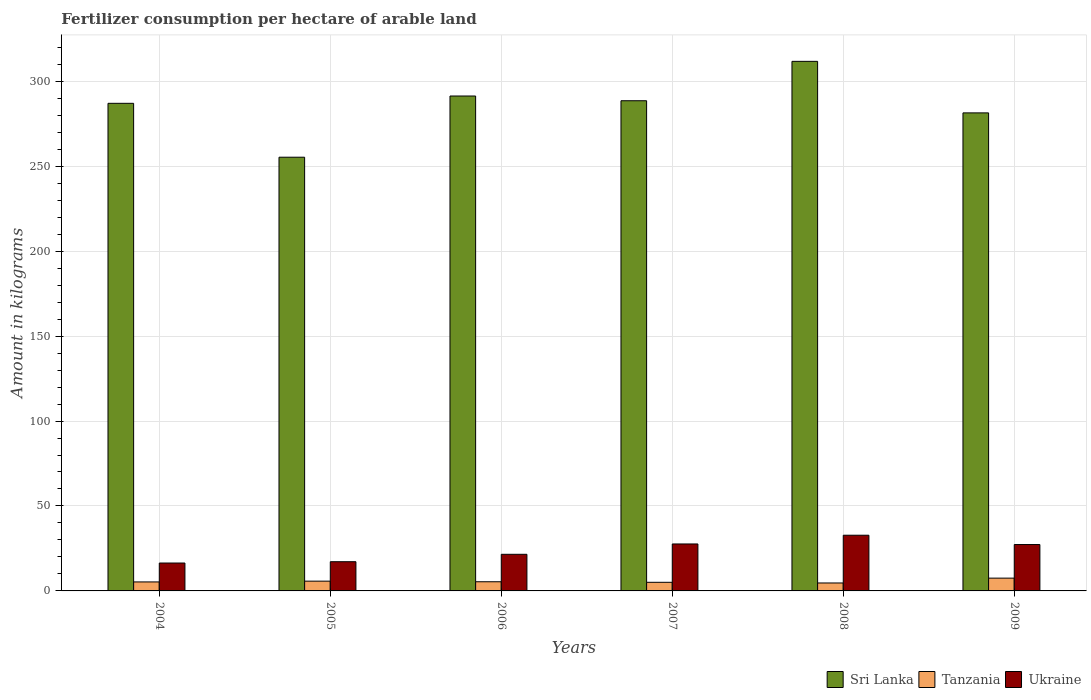Are the number of bars per tick equal to the number of legend labels?
Ensure brevity in your answer.  Yes. Are the number of bars on each tick of the X-axis equal?
Your answer should be compact. Yes. How many bars are there on the 3rd tick from the right?
Provide a short and direct response. 3. What is the label of the 4th group of bars from the left?
Offer a terse response. 2007. In how many cases, is the number of bars for a given year not equal to the number of legend labels?
Offer a terse response. 0. What is the amount of fertilizer consumption in Tanzania in 2006?
Your response must be concise. 5.4. Across all years, what is the maximum amount of fertilizer consumption in Ukraine?
Provide a short and direct response. 32.79. Across all years, what is the minimum amount of fertilizer consumption in Tanzania?
Ensure brevity in your answer.  4.68. In which year was the amount of fertilizer consumption in Sri Lanka minimum?
Your answer should be compact. 2005. What is the total amount of fertilizer consumption in Ukraine in the graph?
Provide a short and direct response. 142.89. What is the difference between the amount of fertilizer consumption in Tanzania in 2004 and that in 2008?
Ensure brevity in your answer.  0.61. What is the difference between the amount of fertilizer consumption in Ukraine in 2005 and the amount of fertilizer consumption in Sri Lanka in 2009?
Your response must be concise. -264.18. What is the average amount of fertilizer consumption in Sri Lanka per year?
Make the answer very short. 285.87. In the year 2004, what is the difference between the amount of fertilizer consumption in Ukraine and amount of fertilizer consumption in Tanzania?
Provide a short and direct response. 11.13. What is the ratio of the amount of fertilizer consumption in Tanzania in 2004 to that in 2006?
Your answer should be very brief. 0.98. What is the difference between the highest and the second highest amount of fertilizer consumption in Ukraine?
Keep it short and to the point. 5.15. What is the difference between the highest and the lowest amount of fertilizer consumption in Ukraine?
Keep it short and to the point. 16.37. Is the sum of the amount of fertilizer consumption in Tanzania in 2004 and 2006 greater than the maximum amount of fertilizer consumption in Ukraine across all years?
Your response must be concise. No. What does the 1st bar from the left in 2005 represents?
Provide a succinct answer. Sri Lanka. What does the 2nd bar from the right in 2004 represents?
Your answer should be compact. Tanzania. Are all the bars in the graph horizontal?
Your answer should be compact. No. Are the values on the major ticks of Y-axis written in scientific E-notation?
Keep it short and to the point. No. Does the graph contain grids?
Give a very brief answer. Yes. Where does the legend appear in the graph?
Your answer should be very brief. Bottom right. How are the legend labels stacked?
Your response must be concise. Horizontal. What is the title of the graph?
Provide a succinct answer. Fertilizer consumption per hectare of arable land. What is the label or title of the Y-axis?
Make the answer very short. Amount in kilograms. What is the Amount in kilograms of Sri Lanka in 2004?
Your answer should be compact. 287.01. What is the Amount in kilograms in Tanzania in 2004?
Provide a succinct answer. 5.29. What is the Amount in kilograms of Ukraine in 2004?
Make the answer very short. 16.42. What is the Amount in kilograms in Sri Lanka in 2005?
Give a very brief answer. 255.29. What is the Amount in kilograms in Tanzania in 2005?
Offer a terse response. 5.75. What is the Amount in kilograms in Ukraine in 2005?
Your response must be concise. 17.19. What is the Amount in kilograms of Sri Lanka in 2006?
Keep it short and to the point. 291.32. What is the Amount in kilograms of Tanzania in 2006?
Offer a terse response. 5.4. What is the Amount in kilograms of Ukraine in 2006?
Make the answer very short. 21.55. What is the Amount in kilograms in Sri Lanka in 2007?
Keep it short and to the point. 288.52. What is the Amount in kilograms in Tanzania in 2007?
Give a very brief answer. 5.07. What is the Amount in kilograms of Ukraine in 2007?
Offer a very short reply. 27.64. What is the Amount in kilograms in Sri Lanka in 2008?
Provide a short and direct response. 311.71. What is the Amount in kilograms in Tanzania in 2008?
Provide a succinct answer. 4.68. What is the Amount in kilograms of Ukraine in 2008?
Provide a succinct answer. 32.79. What is the Amount in kilograms of Sri Lanka in 2009?
Give a very brief answer. 281.38. What is the Amount in kilograms of Tanzania in 2009?
Provide a succinct answer. 7.52. What is the Amount in kilograms in Ukraine in 2009?
Provide a succinct answer. 27.3. Across all years, what is the maximum Amount in kilograms in Sri Lanka?
Give a very brief answer. 311.71. Across all years, what is the maximum Amount in kilograms of Tanzania?
Offer a very short reply. 7.52. Across all years, what is the maximum Amount in kilograms in Ukraine?
Give a very brief answer. 32.79. Across all years, what is the minimum Amount in kilograms in Sri Lanka?
Provide a succinct answer. 255.29. Across all years, what is the minimum Amount in kilograms in Tanzania?
Provide a succinct answer. 4.68. Across all years, what is the minimum Amount in kilograms of Ukraine?
Your answer should be very brief. 16.42. What is the total Amount in kilograms of Sri Lanka in the graph?
Make the answer very short. 1715.23. What is the total Amount in kilograms in Tanzania in the graph?
Offer a terse response. 33.71. What is the total Amount in kilograms of Ukraine in the graph?
Give a very brief answer. 142.89. What is the difference between the Amount in kilograms in Sri Lanka in 2004 and that in 2005?
Keep it short and to the point. 31.72. What is the difference between the Amount in kilograms in Tanzania in 2004 and that in 2005?
Keep it short and to the point. -0.47. What is the difference between the Amount in kilograms of Ukraine in 2004 and that in 2005?
Your answer should be very brief. -0.77. What is the difference between the Amount in kilograms of Sri Lanka in 2004 and that in 2006?
Your answer should be very brief. -4.31. What is the difference between the Amount in kilograms of Tanzania in 2004 and that in 2006?
Keep it short and to the point. -0.11. What is the difference between the Amount in kilograms of Ukraine in 2004 and that in 2006?
Your answer should be very brief. -5.14. What is the difference between the Amount in kilograms of Sri Lanka in 2004 and that in 2007?
Your answer should be compact. -1.51. What is the difference between the Amount in kilograms of Tanzania in 2004 and that in 2007?
Offer a very short reply. 0.22. What is the difference between the Amount in kilograms in Ukraine in 2004 and that in 2007?
Your answer should be compact. -11.22. What is the difference between the Amount in kilograms of Sri Lanka in 2004 and that in 2008?
Your answer should be very brief. -24.7. What is the difference between the Amount in kilograms of Tanzania in 2004 and that in 2008?
Offer a terse response. 0.61. What is the difference between the Amount in kilograms of Ukraine in 2004 and that in 2008?
Make the answer very short. -16.37. What is the difference between the Amount in kilograms of Sri Lanka in 2004 and that in 2009?
Your response must be concise. 5.63. What is the difference between the Amount in kilograms in Tanzania in 2004 and that in 2009?
Offer a very short reply. -2.24. What is the difference between the Amount in kilograms of Ukraine in 2004 and that in 2009?
Your answer should be compact. -10.89. What is the difference between the Amount in kilograms in Sri Lanka in 2005 and that in 2006?
Offer a very short reply. -36.02. What is the difference between the Amount in kilograms of Tanzania in 2005 and that in 2006?
Provide a succinct answer. 0.36. What is the difference between the Amount in kilograms of Ukraine in 2005 and that in 2006?
Ensure brevity in your answer.  -4.36. What is the difference between the Amount in kilograms of Sri Lanka in 2005 and that in 2007?
Keep it short and to the point. -33.23. What is the difference between the Amount in kilograms of Tanzania in 2005 and that in 2007?
Provide a succinct answer. 0.68. What is the difference between the Amount in kilograms of Ukraine in 2005 and that in 2007?
Your answer should be compact. -10.45. What is the difference between the Amount in kilograms in Sri Lanka in 2005 and that in 2008?
Ensure brevity in your answer.  -56.42. What is the difference between the Amount in kilograms in Tanzania in 2005 and that in 2008?
Offer a terse response. 1.08. What is the difference between the Amount in kilograms of Ukraine in 2005 and that in 2008?
Keep it short and to the point. -15.59. What is the difference between the Amount in kilograms in Sri Lanka in 2005 and that in 2009?
Make the answer very short. -26.08. What is the difference between the Amount in kilograms of Tanzania in 2005 and that in 2009?
Keep it short and to the point. -1.77. What is the difference between the Amount in kilograms in Ukraine in 2005 and that in 2009?
Offer a very short reply. -10.11. What is the difference between the Amount in kilograms in Sri Lanka in 2006 and that in 2007?
Offer a very short reply. 2.79. What is the difference between the Amount in kilograms in Tanzania in 2006 and that in 2007?
Offer a terse response. 0.33. What is the difference between the Amount in kilograms of Ukraine in 2006 and that in 2007?
Your answer should be compact. -6.09. What is the difference between the Amount in kilograms of Sri Lanka in 2006 and that in 2008?
Your response must be concise. -20.4. What is the difference between the Amount in kilograms of Tanzania in 2006 and that in 2008?
Provide a short and direct response. 0.72. What is the difference between the Amount in kilograms in Ukraine in 2006 and that in 2008?
Offer a very short reply. -11.23. What is the difference between the Amount in kilograms of Sri Lanka in 2006 and that in 2009?
Your answer should be very brief. 9.94. What is the difference between the Amount in kilograms in Tanzania in 2006 and that in 2009?
Ensure brevity in your answer.  -2.13. What is the difference between the Amount in kilograms in Ukraine in 2006 and that in 2009?
Give a very brief answer. -5.75. What is the difference between the Amount in kilograms in Sri Lanka in 2007 and that in 2008?
Make the answer very short. -23.19. What is the difference between the Amount in kilograms of Tanzania in 2007 and that in 2008?
Offer a terse response. 0.4. What is the difference between the Amount in kilograms of Ukraine in 2007 and that in 2008?
Your response must be concise. -5.15. What is the difference between the Amount in kilograms of Sri Lanka in 2007 and that in 2009?
Keep it short and to the point. 7.15. What is the difference between the Amount in kilograms of Tanzania in 2007 and that in 2009?
Your answer should be very brief. -2.45. What is the difference between the Amount in kilograms of Ukraine in 2007 and that in 2009?
Ensure brevity in your answer.  0.34. What is the difference between the Amount in kilograms in Sri Lanka in 2008 and that in 2009?
Ensure brevity in your answer.  30.34. What is the difference between the Amount in kilograms in Tanzania in 2008 and that in 2009?
Keep it short and to the point. -2.85. What is the difference between the Amount in kilograms in Ukraine in 2008 and that in 2009?
Your response must be concise. 5.48. What is the difference between the Amount in kilograms of Sri Lanka in 2004 and the Amount in kilograms of Tanzania in 2005?
Your answer should be compact. 281.26. What is the difference between the Amount in kilograms of Sri Lanka in 2004 and the Amount in kilograms of Ukraine in 2005?
Keep it short and to the point. 269.82. What is the difference between the Amount in kilograms of Tanzania in 2004 and the Amount in kilograms of Ukraine in 2005?
Provide a short and direct response. -11.9. What is the difference between the Amount in kilograms of Sri Lanka in 2004 and the Amount in kilograms of Tanzania in 2006?
Provide a succinct answer. 281.61. What is the difference between the Amount in kilograms of Sri Lanka in 2004 and the Amount in kilograms of Ukraine in 2006?
Your response must be concise. 265.46. What is the difference between the Amount in kilograms of Tanzania in 2004 and the Amount in kilograms of Ukraine in 2006?
Your answer should be compact. -16.26. What is the difference between the Amount in kilograms of Sri Lanka in 2004 and the Amount in kilograms of Tanzania in 2007?
Ensure brevity in your answer.  281.94. What is the difference between the Amount in kilograms of Sri Lanka in 2004 and the Amount in kilograms of Ukraine in 2007?
Keep it short and to the point. 259.37. What is the difference between the Amount in kilograms in Tanzania in 2004 and the Amount in kilograms in Ukraine in 2007?
Give a very brief answer. -22.35. What is the difference between the Amount in kilograms in Sri Lanka in 2004 and the Amount in kilograms in Tanzania in 2008?
Ensure brevity in your answer.  282.33. What is the difference between the Amount in kilograms of Sri Lanka in 2004 and the Amount in kilograms of Ukraine in 2008?
Give a very brief answer. 254.22. What is the difference between the Amount in kilograms of Tanzania in 2004 and the Amount in kilograms of Ukraine in 2008?
Give a very brief answer. -27.5. What is the difference between the Amount in kilograms in Sri Lanka in 2004 and the Amount in kilograms in Tanzania in 2009?
Provide a short and direct response. 279.49. What is the difference between the Amount in kilograms of Sri Lanka in 2004 and the Amount in kilograms of Ukraine in 2009?
Provide a short and direct response. 259.71. What is the difference between the Amount in kilograms of Tanzania in 2004 and the Amount in kilograms of Ukraine in 2009?
Keep it short and to the point. -22.01. What is the difference between the Amount in kilograms of Sri Lanka in 2005 and the Amount in kilograms of Tanzania in 2006?
Keep it short and to the point. 249.89. What is the difference between the Amount in kilograms of Sri Lanka in 2005 and the Amount in kilograms of Ukraine in 2006?
Ensure brevity in your answer.  233.74. What is the difference between the Amount in kilograms in Tanzania in 2005 and the Amount in kilograms in Ukraine in 2006?
Keep it short and to the point. -15.8. What is the difference between the Amount in kilograms of Sri Lanka in 2005 and the Amount in kilograms of Tanzania in 2007?
Your answer should be very brief. 250.22. What is the difference between the Amount in kilograms in Sri Lanka in 2005 and the Amount in kilograms in Ukraine in 2007?
Offer a very short reply. 227.65. What is the difference between the Amount in kilograms of Tanzania in 2005 and the Amount in kilograms of Ukraine in 2007?
Make the answer very short. -21.88. What is the difference between the Amount in kilograms of Sri Lanka in 2005 and the Amount in kilograms of Tanzania in 2008?
Provide a short and direct response. 250.62. What is the difference between the Amount in kilograms of Sri Lanka in 2005 and the Amount in kilograms of Ukraine in 2008?
Offer a terse response. 222.5. What is the difference between the Amount in kilograms in Tanzania in 2005 and the Amount in kilograms in Ukraine in 2008?
Your answer should be very brief. -27.03. What is the difference between the Amount in kilograms of Sri Lanka in 2005 and the Amount in kilograms of Tanzania in 2009?
Ensure brevity in your answer.  247.77. What is the difference between the Amount in kilograms in Sri Lanka in 2005 and the Amount in kilograms in Ukraine in 2009?
Ensure brevity in your answer.  227.99. What is the difference between the Amount in kilograms of Tanzania in 2005 and the Amount in kilograms of Ukraine in 2009?
Give a very brief answer. -21.55. What is the difference between the Amount in kilograms of Sri Lanka in 2006 and the Amount in kilograms of Tanzania in 2007?
Provide a short and direct response. 286.24. What is the difference between the Amount in kilograms in Sri Lanka in 2006 and the Amount in kilograms in Ukraine in 2007?
Ensure brevity in your answer.  263.68. What is the difference between the Amount in kilograms in Tanzania in 2006 and the Amount in kilograms in Ukraine in 2007?
Keep it short and to the point. -22.24. What is the difference between the Amount in kilograms of Sri Lanka in 2006 and the Amount in kilograms of Tanzania in 2008?
Give a very brief answer. 286.64. What is the difference between the Amount in kilograms of Sri Lanka in 2006 and the Amount in kilograms of Ukraine in 2008?
Provide a short and direct response. 258.53. What is the difference between the Amount in kilograms of Tanzania in 2006 and the Amount in kilograms of Ukraine in 2008?
Your response must be concise. -27.39. What is the difference between the Amount in kilograms of Sri Lanka in 2006 and the Amount in kilograms of Tanzania in 2009?
Keep it short and to the point. 283.79. What is the difference between the Amount in kilograms of Sri Lanka in 2006 and the Amount in kilograms of Ukraine in 2009?
Provide a succinct answer. 264.01. What is the difference between the Amount in kilograms in Tanzania in 2006 and the Amount in kilograms in Ukraine in 2009?
Make the answer very short. -21.91. What is the difference between the Amount in kilograms of Sri Lanka in 2007 and the Amount in kilograms of Tanzania in 2008?
Offer a very short reply. 283.85. What is the difference between the Amount in kilograms of Sri Lanka in 2007 and the Amount in kilograms of Ukraine in 2008?
Provide a succinct answer. 255.74. What is the difference between the Amount in kilograms of Tanzania in 2007 and the Amount in kilograms of Ukraine in 2008?
Your answer should be compact. -27.72. What is the difference between the Amount in kilograms of Sri Lanka in 2007 and the Amount in kilograms of Tanzania in 2009?
Your response must be concise. 281. What is the difference between the Amount in kilograms in Sri Lanka in 2007 and the Amount in kilograms in Ukraine in 2009?
Provide a succinct answer. 261.22. What is the difference between the Amount in kilograms of Tanzania in 2007 and the Amount in kilograms of Ukraine in 2009?
Provide a short and direct response. -22.23. What is the difference between the Amount in kilograms of Sri Lanka in 2008 and the Amount in kilograms of Tanzania in 2009?
Your response must be concise. 304.19. What is the difference between the Amount in kilograms in Sri Lanka in 2008 and the Amount in kilograms in Ukraine in 2009?
Your answer should be compact. 284.41. What is the difference between the Amount in kilograms in Tanzania in 2008 and the Amount in kilograms in Ukraine in 2009?
Ensure brevity in your answer.  -22.63. What is the average Amount in kilograms of Sri Lanka per year?
Ensure brevity in your answer.  285.87. What is the average Amount in kilograms of Tanzania per year?
Provide a short and direct response. 5.62. What is the average Amount in kilograms in Ukraine per year?
Ensure brevity in your answer.  23.82. In the year 2004, what is the difference between the Amount in kilograms of Sri Lanka and Amount in kilograms of Tanzania?
Your answer should be compact. 281.72. In the year 2004, what is the difference between the Amount in kilograms of Sri Lanka and Amount in kilograms of Ukraine?
Provide a short and direct response. 270.59. In the year 2004, what is the difference between the Amount in kilograms in Tanzania and Amount in kilograms in Ukraine?
Give a very brief answer. -11.13. In the year 2005, what is the difference between the Amount in kilograms of Sri Lanka and Amount in kilograms of Tanzania?
Your response must be concise. 249.54. In the year 2005, what is the difference between the Amount in kilograms in Sri Lanka and Amount in kilograms in Ukraine?
Your answer should be compact. 238.1. In the year 2005, what is the difference between the Amount in kilograms in Tanzania and Amount in kilograms in Ukraine?
Give a very brief answer. -11.44. In the year 2006, what is the difference between the Amount in kilograms of Sri Lanka and Amount in kilograms of Tanzania?
Ensure brevity in your answer.  285.92. In the year 2006, what is the difference between the Amount in kilograms of Sri Lanka and Amount in kilograms of Ukraine?
Provide a succinct answer. 269.76. In the year 2006, what is the difference between the Amount in kilograms in Tanzania and Amount in kilograms in Ukraine?
Give a very brief answer. -16.16. In the year 2007, what is the difference between the Amount in kilograms of Sri Lanka and Amount in kilograms of Tanzania?
Provide a succinct answer. 283.45. In the year 2007, what is the difference between the Amount in kilograms in Sri Lanka and Amount in kilograms in Ukraine?
Give a very brief answer. 260.89. In the year 2007, what is the difference between the Amount in kilograms of Tanzania and Amount in kilograms of Ukraine?
Offer a very short reply. -22.57. In the year 2008, what is the difference between the Amount in kilograms of Sri Lanka and Amount in kilograms of Tanzania?
Ensure brevity in your answer.  307.04. In the year 2008, what is the difference between the Amount in kilograms of Sri Lanka and Amount in kilograms of Ukraine?
Offer a very short reply. 278.92. In the year 2008, what is the difference between the Amount in kilograms in Tanzania and Amount in kilograms in Ukraine?
Offer a terse response. -28.11. In the year 2009, what is the difference between the Amount in kilograms in Sri Lanka and Amount in kilograms in Tanzania?
Your answer should be compact. 273.85. In the year 2009, what is the difference between the Amount in kilograms in Sri Lanka and Amount in kilograms in Ukraine?
Your response must be concise. 254.07. In the year 2009, what is the difference between the Amount in kilograms in Tanzania and Amount in kilograms in Ukraine?
Keep it short and to the point. -19.78. What is the ratio of the Amount in kilograms of Sri Lanka in 2004 to that in 2005?
Make the answer very short. 1.12. What is the ratio of the Amount in kilograms of Tanzania in 2004 to that in 2005?
Give a very brief answer. 0.92. What is the ratio of the Amount in kilograms of Ukraine in 2004 to that in 2005?
Provide a short and direct response. 0.95. What is the ratio of the Amount in kilograms of Sri Lanka in 2004 to that in 2006?
Make the answer very short. 0.99. What is the ratio of the Amount in kilograms in Tanzania in 2004 to that in 2006?
Your answer should be compact. 0.98. What is the ratio of the Amount in kilograms in Ukraine in 2004 to that in 2006?
Your answer should be very brief. 0.76. What is the ratio of the Amount in kilograms of Tanzania in 2004 to that in 2007?
Offer a very short reply. 1.04. What is the ratio of the Amount in kilograms in Ukraine in 2004 to that in 2007?
Offer a very short reply. 0.59. What is the ratio of the Amount in kilograms of Sri Lanka in 2004 to that in 2008?
Your answer should be compact. 0.92. What is the ratio of the Amount in kilograms in Tanzania in 2004 to that in 2008?
Give a very brief answer. 1.13. What is the ratio of the Amount in kilograms of Ukraine in 2004 to that in 2008?
Ensure brevity in your answer.  0.5. What is the ratio of the Amount in kilograms in Tanzania in 2004 to that in 2009?
Your answer should be very brief. 0.7. What is the ratio of the Amount in kilograms in Ukraine in 2004 to that in 2009?
Your answer should be very brief. 0.6. What is the ratio of the Amount in kilograms of Sri Lanka in 2005 to that in 2006?
Ensure brevity in your answer.  0.88. What is the ratio of the Amount in kilograms in Tanzania in 2005 to that in 2006?
Give a very brief answer. 1.07. What is the ratio of the Amount in kilograms of Ukraine in 2005 to that in 2006?
Provide a succinct answer. 0.8. What is the ratio of the Amount in kilograms of Sri Lanka in 2005 to that in 2007?
Provide a short and direct response. 0.88. What is the ratio of the Amount in kilograms of Tanzania in 2005 to that in 2007?
Make the answer very short. 1.13. What is the ratio of the Amount in kilograms in Ukraine in 2005 to that in 2007?
Provide a succinct answer. 0.62. What is the ratio of the Amount in kilograms in Sri Lanka in 2005 to that in 2008?
Your answer should be very brief. 0.82. What is the ratio of the Amount in kilograms in Tanzania in 2005 to that in 2008?
Make the answer very short. 1.23. What is the ratio of the Amount in kilograms in Ukraine in 2005 to that in 2008?
Provide a short and direct response. 0.52. What is the ratio of the Amount in kilograms in Sri Lanka in 2005 to that in 2009?
Ensure brevity in your answer.  0.91. What is the ratio of the Amount in kilograms of Tanzania in 2005 to that in 2009?
Keep it short and to the point. 0.76. What is the ratio of the Amount in kilograms in Ukraine in 2005 to that in 2009?
Give a very brief answer. 0.63. What is the ratio of the Amount in kilograms in Sri Lanka in 2006 to that in 2007?
Your response must be concise. 1.01. What is the ratio of the Amount in kilograms in Tanzania in 2006 to that in 2007?
Your answer should be very brief. 1.06. What is the ratio of the Amount in kilograms of Ukraine in 2006 to that in 2007?
Provide a succinct answer. 0.78. What is the ratio of the Amount in kilograms of Sri Lanka in 2006 to that in 2008?
Your answer should be very brief. 0.93. What is the ratio of the Amount in kilograms in Tanzania in 2006 to that in 2008?
Provide a succinct answer. 1.15. What is the ratio of the Amount in kilograms in Ukraine in 2006 to that in 2008?
Give a very brief answer. 0.66. What is the ratio of the Amount in kilograms of Sri Lanka in 2006 to that in 2009?
Ensure brevity in your answer.  1.04. What is the ratio of the Amount in kilograms in Tanzania in 2006 to that in 2009?
Your answer should be very brief. 0.72. What is the ratio of the Amount in kilograms in Ukraine in 2006 to that in 2009?
Your response must be concise. 0.79. What is the ratio of the Amount in kilograms in Sri Lanka in 2007 to that in 2008?
Offer a very short reply. 0.93. What is the ratio of the Amount in kilograms of Tanzania in 2007 to that in 2008?
Offer a terse response. 1.08. What is the ratio of the Amount in kilograms of Ukraine in 2007 to that in 2008?
Ensure brevity in your answer.  0.84. What is the ratio of the Amount in kilograms of Sri Lanka in 2007 to that in 2009?
Give a very brief answer. 1.03. What is the ratio of the Amount in kilograms of Tanzania in 2007 to that in 2009?
Keep it short and to the point. 0.67. What is the ratio of the Amount in kilograms of Ukraine in 2007 to that in 2009?
Keep it short and to the point. 1.01. What is the ratio of the Amount in kilograms of Sri Lanka in 2008 to that in 2009?
Keep it short and to the point. 1.11. What is the ratio of the Amount in kilograms in Tanzania in 2008 to that in 2009?
Make the answer very short. 0.62. What is the ratio of the Amount in kilograms in Ukraine in 2008 to that in 2009?
Offer a terse response. 1.2. What is the difference between the highest and the second highest Amount in kilograms of Sri Lanka?
Offer a very short reply. 20.4. What is the difference between the highest and the second highest Amount in kilograms in Tanzania?
Provide a succinct answer. 1.77. What is the difference between the highest and the second highest Amount in kilograms of Ukraine?
Your response must be concise. 5.15. What is the difference between the highest and the lowest Amount in kilograms in Sri Lanka?
Offer a very short reply. 56.42. What is the difference between the highest and the lowest Amount in kilograms of Tanzania?
Offer a terse response. 2.85. What is the difference between the highest and the lowest Amount in kilograms of Ukraine?
Give a very brief answer. 16.37. 